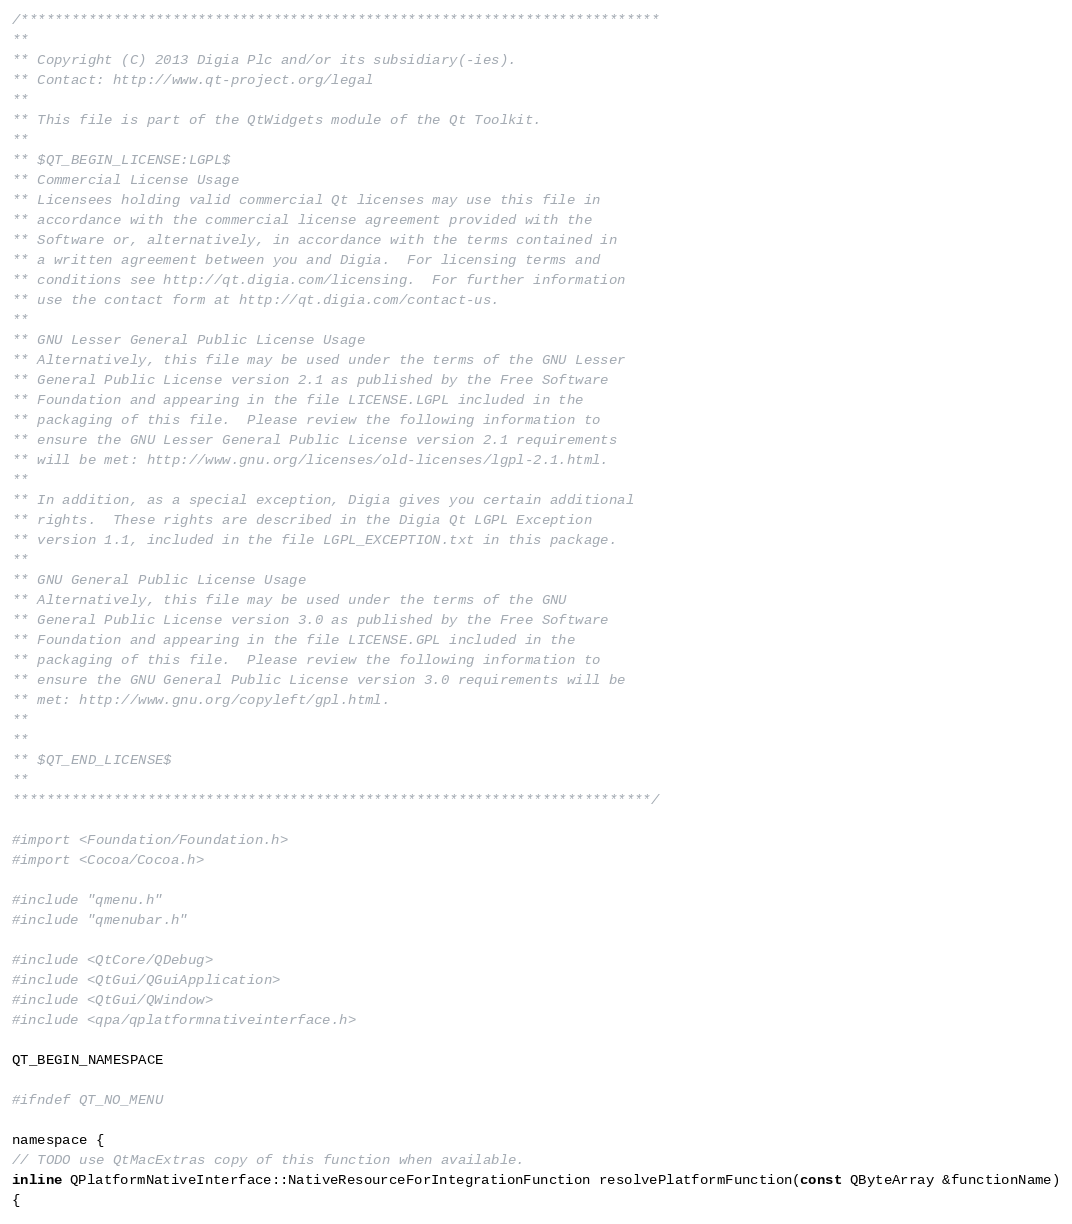Convert code to text. <code><loc_0><loc_0><loc_500><loc_500><_ObjectiveC_>/****************************************************************************
**
** Copyright (C) 2013 Digia Plc and/or its subsidiary(-ies).
** Contact: http://www.qt-project.org/legal
**
** This file is part of the QtWidgets module of the Qt Toolkit.
**
** $QT_BEGIN_LICENSE:LGPL$
** Commercial License Usage
** Licensees holding valid commercial Qt licenses may use this file in
** accordance with the commercial license agreement provided with the
** Software or, alternatively, in accordance with the terms contained in
** a written agreement between you and Digia.  For licensing terms and
** conditions see http://qt.digia.com/licensing.  For further information
** use the contact form at http://qt.digia.com/contact-us.
**
** GNU Lesser General Public License Usage
** Alternatively, this file may be used under the terms of the GNU Lesser
** General Public License version 2.1 as published by the Free Software
** Foundation and appearing in the file LICENSE.LGPL included in the
** packaging of this file.  Please review the following information to
** ensure the GNU Lesser General Public License version 2.1 requirements
** will be met: http://www.gnu.org/licenses/old-licenses/lgpl-2.1.html.
**
** In addition, as a special exception, Digia gives you certain additional
** rights.  These rights are described in the Digia Qt LGPL Exception
** version 1.1, included in the file LGPL_EXCEPTION.txt in this package.
**
** GNU General Public License Usage
** Alternatively, this file may be used under the terms of the GNU
** General Public License version 3.0 as published by the Free Software
** Foundation and appearing in the file LICENSE.GPL included in the
** packaging of this file.  Please review the following information to
** ensure the GNU General Public License version 3.0 requirements will be
** met: http://www.gnu.org/copyleft/gpl.html.
**
**
** $QT_END_LICENSE$
**
****************************************************************************/

#import <Foundation/Foundation.h>
#import <Cocoa/Cocoa.h>

#include "qmenu.h"
#include "qmenubar.h"

#include <QtCore/QDebug>
#include <QtGui/QGuiApplication>
#include <QtGui/QWindow>
#include <qpa/qplatformnativeinterface.h>

QT_BEGIN_NAMESPACE

#ifndef QT_NO_MENU

namespace {
// TODO use QtMacExtras copy of this function when available.
inline QPlatformNativeInterface::NativeResourceForIntegrationFunction resolvePlatformFunction(const QByteArray &functionName)
{</code> 